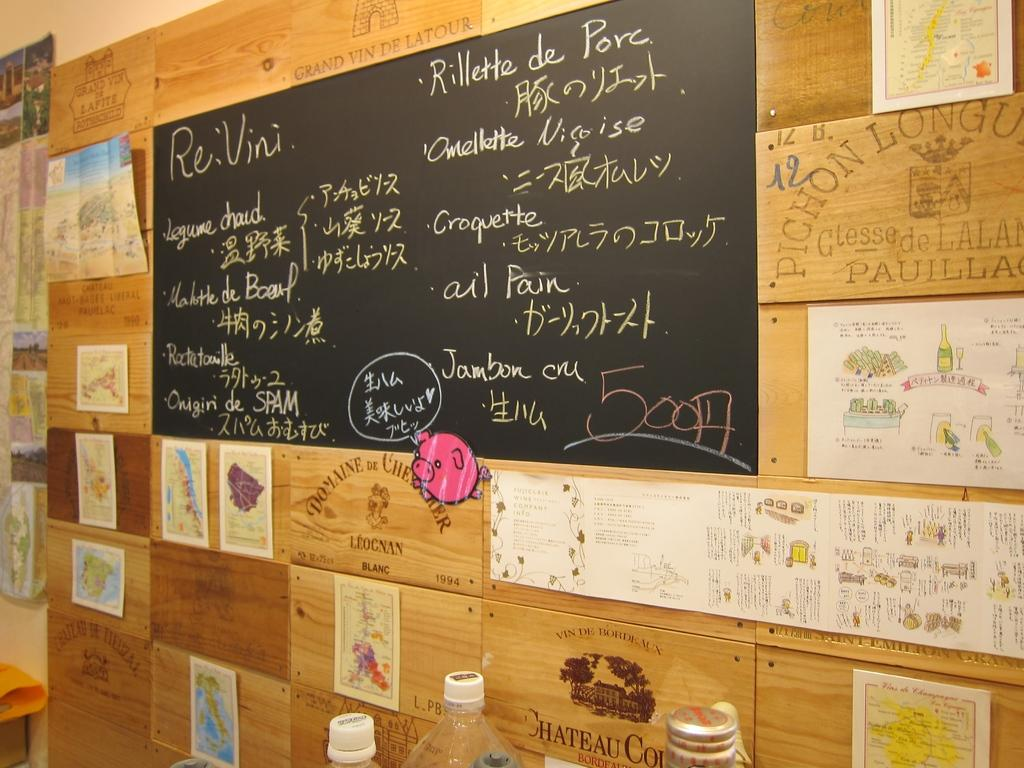<image>
Describe the image concisely. A chalkboard covered in writing with 50014 in the lower right corner. 